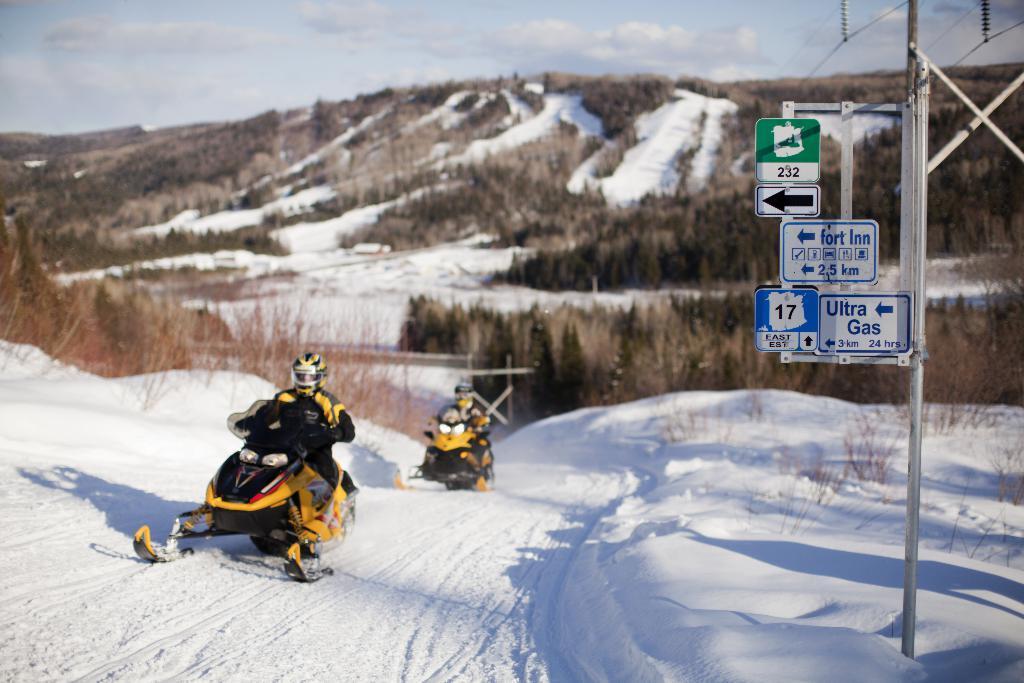Can you describe this image briefly? In this image I can see there are two persons riding on vehicle and I can see a sign board on the right side ,at the top I can see the sky and the hill. 